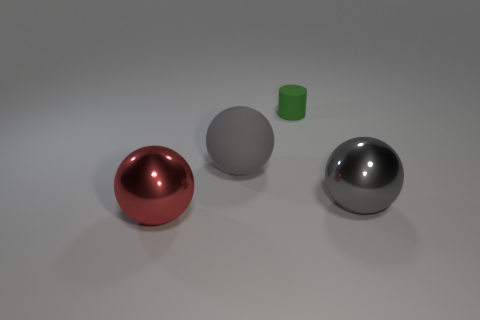Subtract 1 cylinders. How many cylinders are left? 0 Subtract all green spheres. Subtract all cyan cylinders. How many spheres are left? 3 Add 2 blue cylinders. How many objects exist? 6 Subtract all cylinders. How many objects are left? 3 Add 2 brown shiny blocks. How many brown shiny blocks exist? 2 Subtract 0 cyan cubes. How many objects are left? 4 Subtract all big things. Subtract all cylinders. How many objects are left? 0 Add 3 green cylinders. How many green cylinders are left? 4 